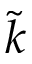<formula> <loc_0><loc_0><loc_500><loc_500>\tilde { k }</formula> 